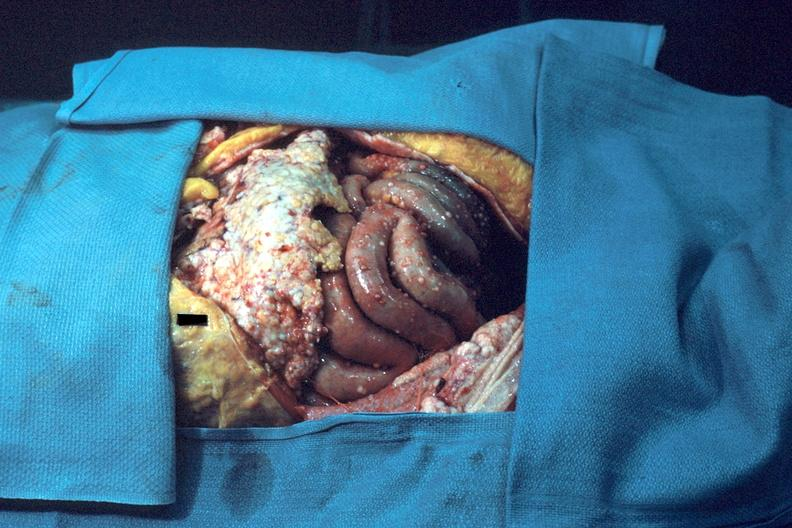s peritoneum present?
Answer the question using a single word or phrase. Yes 